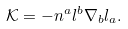<formula> <loc_0><loc_0><loc_500><loc_500>\mathcal { K } = - n ^ { a } l ^ { b } \nabla _ { b } l _ { a } .</formula> 